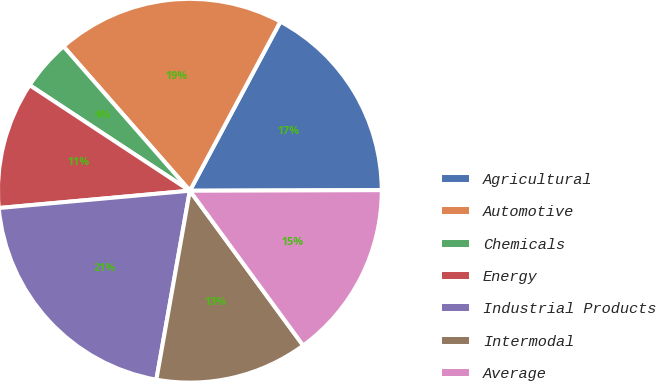<chart> <loc_0><loc_0><loc_500><loc_500><pie_chart><fcel>Agricultural<fcel>Automotive<fcel>Chemicals<fcel>Energy<fcel>Industrial Products<fcel>Intermodal<fcel>Average<nl><fcel>17.13%<fcel>19.27%<fcel>4.28%<fcel>10.71%<fcel>20.77%<fcel>12.85%<fcel>14.99%<nl></chart> 